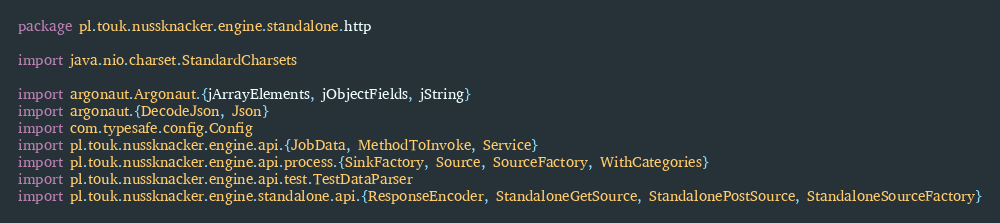Convert code to text. <code><loc_0><loc_0><loc_500><loc_500><_Scala_>package pl.touk.nussknacker.engine.standalone.http

import java.nio.charset.StandardCharsets

import argonaut.Argonaut.{jArrayElements, jObjectFields, jString}
import argonaut.{DecodeJson, Json}
import com.typesafe.config.Config
import pl.touk.nussknacker.engine.api.{JobData, MethodToInvoke, Service}
import pl.touk.nussknacker.engine.api.process.{SinkFactory, Source, SourceFactory, WithCategories}
import pl.touk.nussknacker.engine.api.test.TestDataParser
import pl.touk.nussknacker.engine.standalone.api.{ResponseEncoder, StandaloneGetSource, StandalonePostSource, StandaloneSourceFactory}</code> 